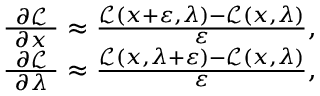Convert formula to latex. <formula><loc_0><loc_0><loc_500><loc_500>{ \begin{array} { r } { { \frac { \ \partial { \mathcal { L } } \ } { \partial x } } \approx { \frac { { \mathcal { L } } ( x + \varepsilon , \lambda ) - { \mathcal { L } } ( x , \lambda ) } { \varepsilon } } , } \\ { { \frac { \ \partial { \mathcal { L } } \ } { \partial \lambda } } \approx { \frac { { \mathcal { L } } ( x , \lambda + \varepsilon ) - { \mathcal { L } } ( x , \lambda ) } { \varepsilon } } , } \end{array} }</formula> 